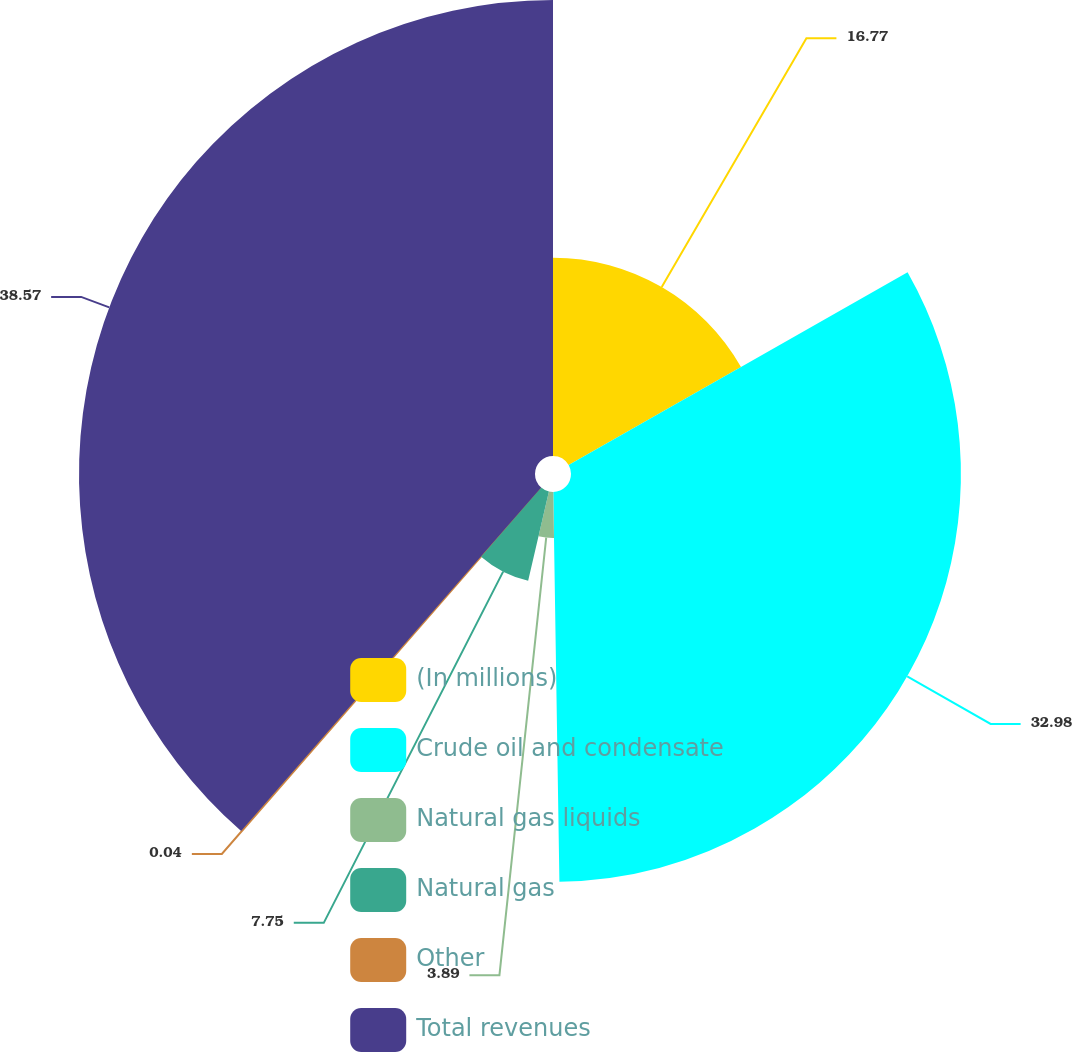Convert chart. <chart><loc_0><loc_0><loc_500><loc_500><pie_chart><fcel>(In millions)<fcel>Crude oil and condensate<fcel>Natural gas liquids<fcel>Natural gas<fcel>Other<fcel>Total revenues<nl><fcel>16.77%<fcel>32.98%<fcel>3.89%<fcel>7.75%<fcel>0.04%<fcel>38.57%<nl></chart> 